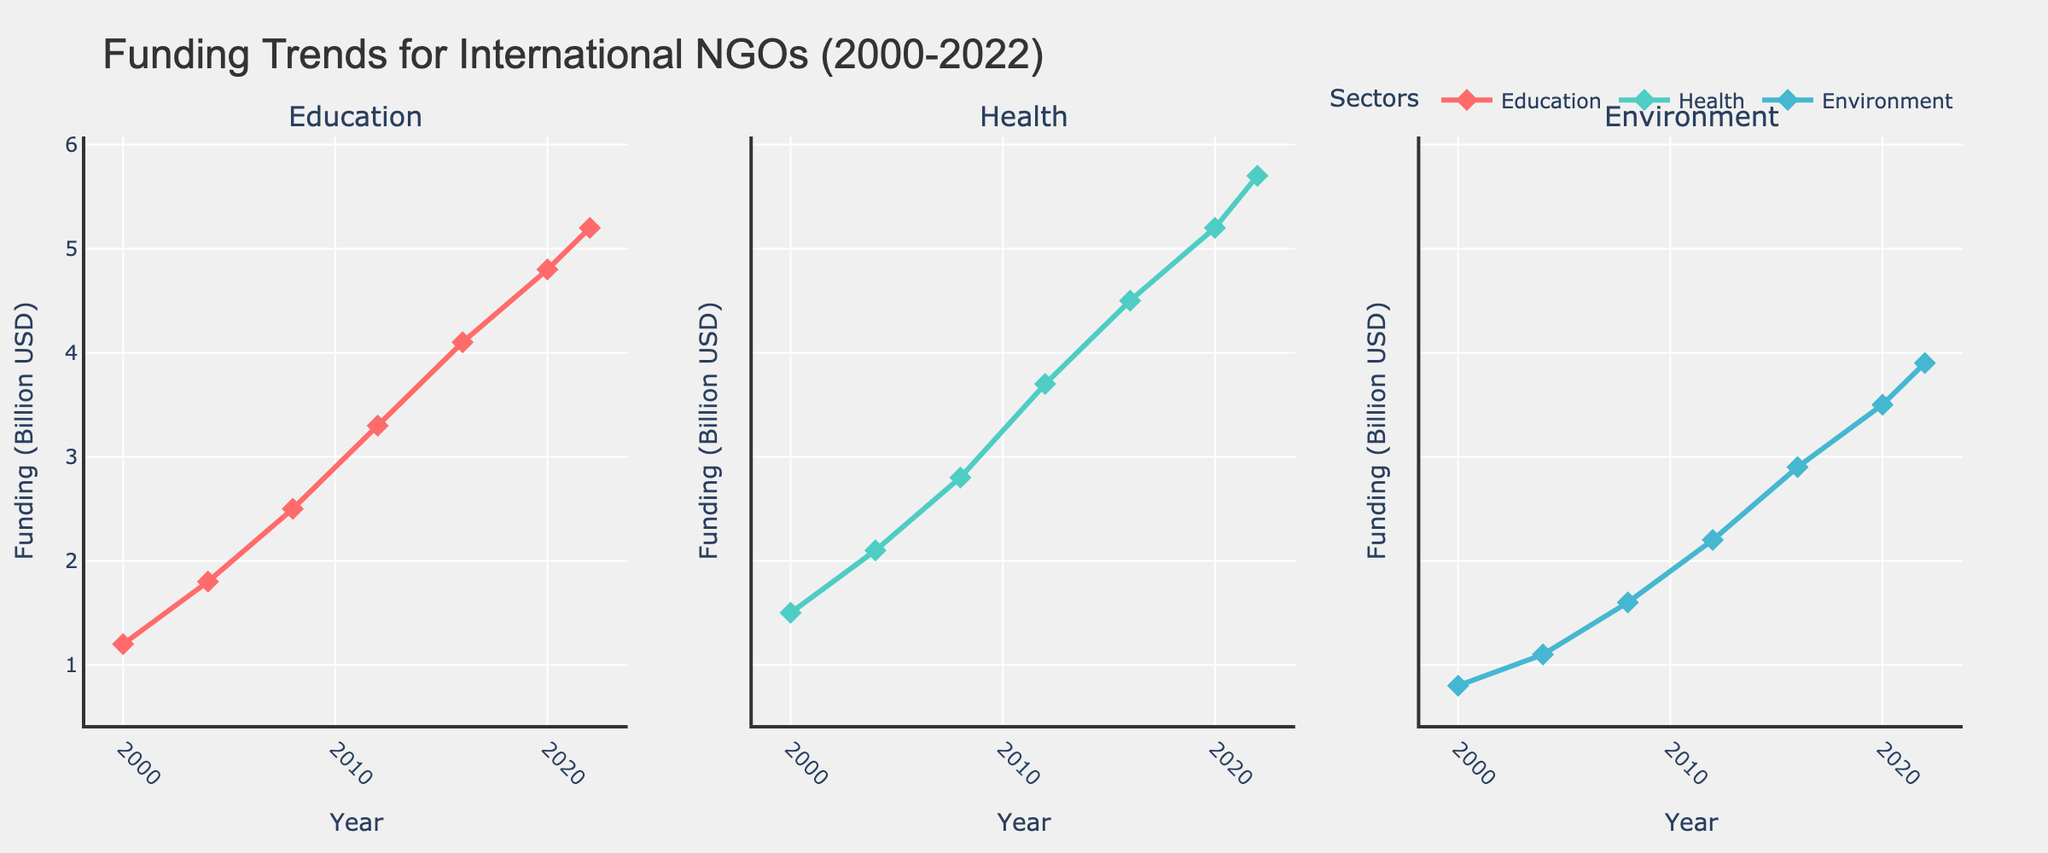Which sector had the highest funding in 2000? The line chart indicates the funding for each sector in different years, represented by lines of different colors. By looking at the values for 2000, Health had the highest funding of 1.5 billion USD, compared to Education (1.2 billion USD) and Environment (0.8 billion USD).
Answer: Health How much did the funding for the Education sector increase from 2000 to 2022? To find the increase, I subtract the Education funding in 2000 from the Education funding in 2022: 5.2 billion USD (2022) - 1.2 billion USD (2000).
Answer: 4.0 billion USD Between which two years did the Health sector experience the greatest increase in funding? We need to compare the increments between each consecutive year for the Health sector. The increases are: 2000-2004: 0.6, 2004-2008: 0.7, 2008-2012: 0.9, 2012-2016: 0.8, 2016-2020: 0.7, 2020-2022: 0.5. The greatest increase was between 2008 and 2012.
Answer: 2008 and 2012 Which sector saw the smallest increase in funding from 2016 to 2022? To find the smallest increase, we need to calculate the increase for each sector between 2016 and 2022. Education: 5.2 - 4.1 = 1.1, Health: 5.7 - 4.5 = 1.2, Environment: 3.9 - 2.9 = 1.0. The Environment sector had the smallest increase.
Answer: Environment During which year did all sectors experience an increase compared to the previous year? Comparing funding amounts between each consecutive year, all sectors saw increases between all years without any decrease. Therefore, all years (2000 to 2022) saw increases in funding compared to the previous years.
Answer: All years Between 2008 and 2012, how did the average funding change for the three sectors combined? The total funding for the three sectors in 2008 is 2.5 (Education) + 2.8 (Health) + 1.6 (Environment) = 6.9. In 2012, it is 3.3 (Education) + 3.7 (Health) + 2.2 (Environment) = 9.2. The average funding in 2008 was 6.9 / 3 = 2.3 and in 2012 it was 9.2 / 3 = 3.07. The change is 3.07 - 2.3.
Answer: 0.77 billion USD Which sector had the steadiest increase over the given period? By observing the trends of the line charts, the Education sector shows a relatively steady increase in funding from 2000 to 2022 without any major fluctuations.
Answer: Education What was the average funding for the Health sector over the entire period? Adding the funding values for the Health sector from all the given years: 1.5 + 2.1 + 2.8 + 3.7 + 4.5 + 5.2 + 5.7 = 25.5, then dividing by the number of data points (7): 25.5 / 7.
Answer: 3.64 billion USD 